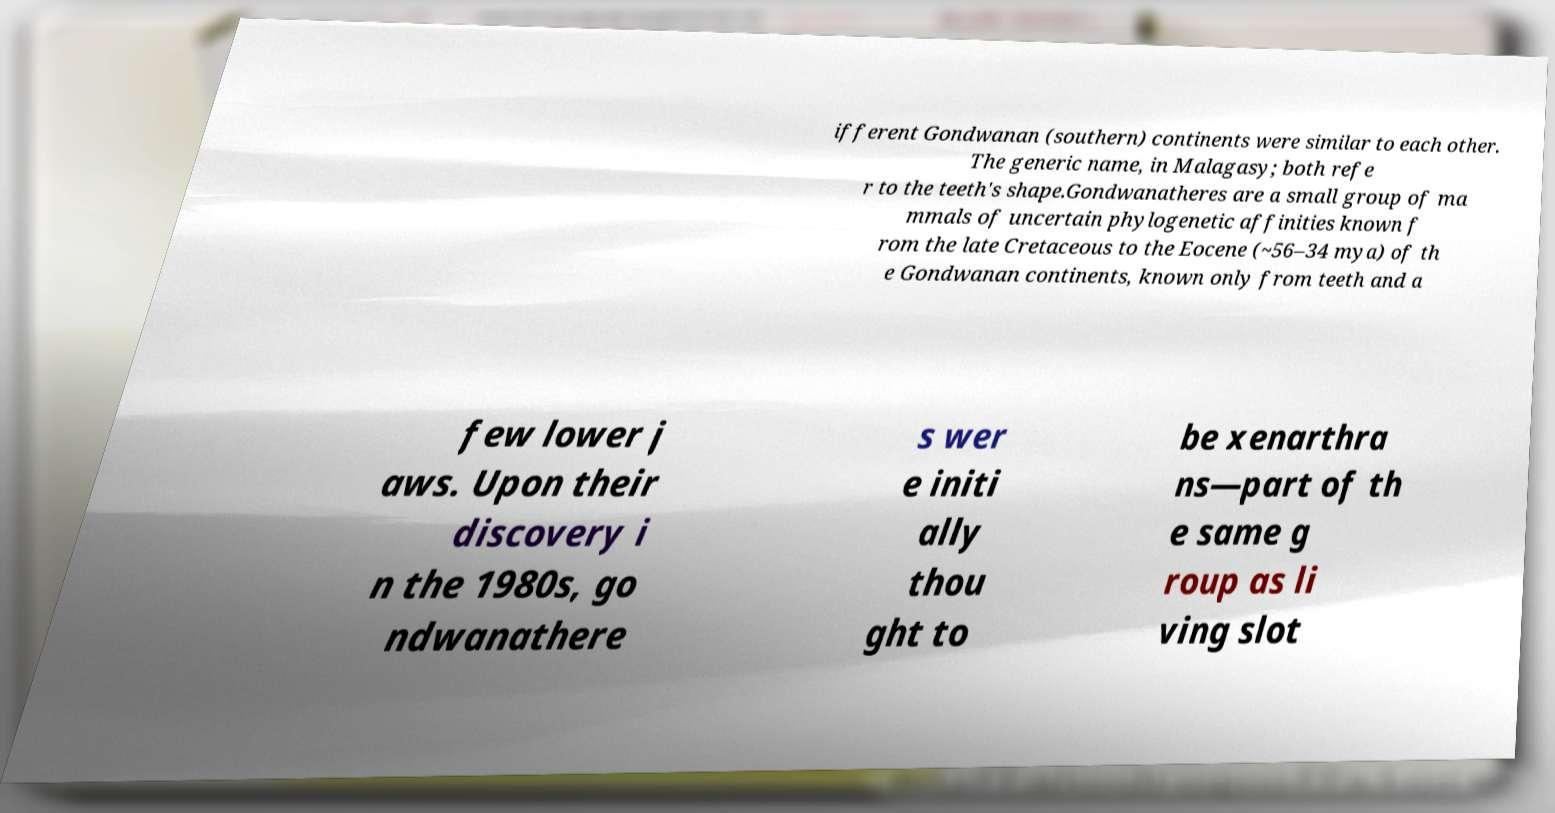Can you accurately transcribe the text from the provided image for me? ifferent Gondwanan (southern) continents were similar to each other. The generic name, in Malagasy; both refe r to the teeth's shape.Gondwanatheres are a small group of ma mmals of uncertain phylogenetic affinities known f rom the late Cretaceous to the Eocene (~56–34 mya) of th e Gondwanan continents, known only from teeth and a few lower j aws. Upon their discovery i n the 1980s, go ndwanathere s wer e initi ally thou ght to be xenarthra ns—part of th e same g roup as li ving slot 